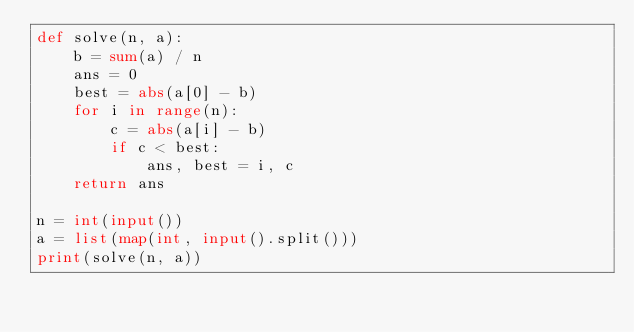Convert code to text. <code><loc_0><loc_0><loc_500><loc_500><_Python_>def solve(n, a):
    b = sum(a) / n
    ans = 0
    best = abs(a[0] - b)
    for i in range(n):
        c = abs(a[i] - b)
        if c < best:
            ans, best = i, c
    return ans

n = int(input())
a = list(map(int, input().split()))
print(solve(n, a))</code> 